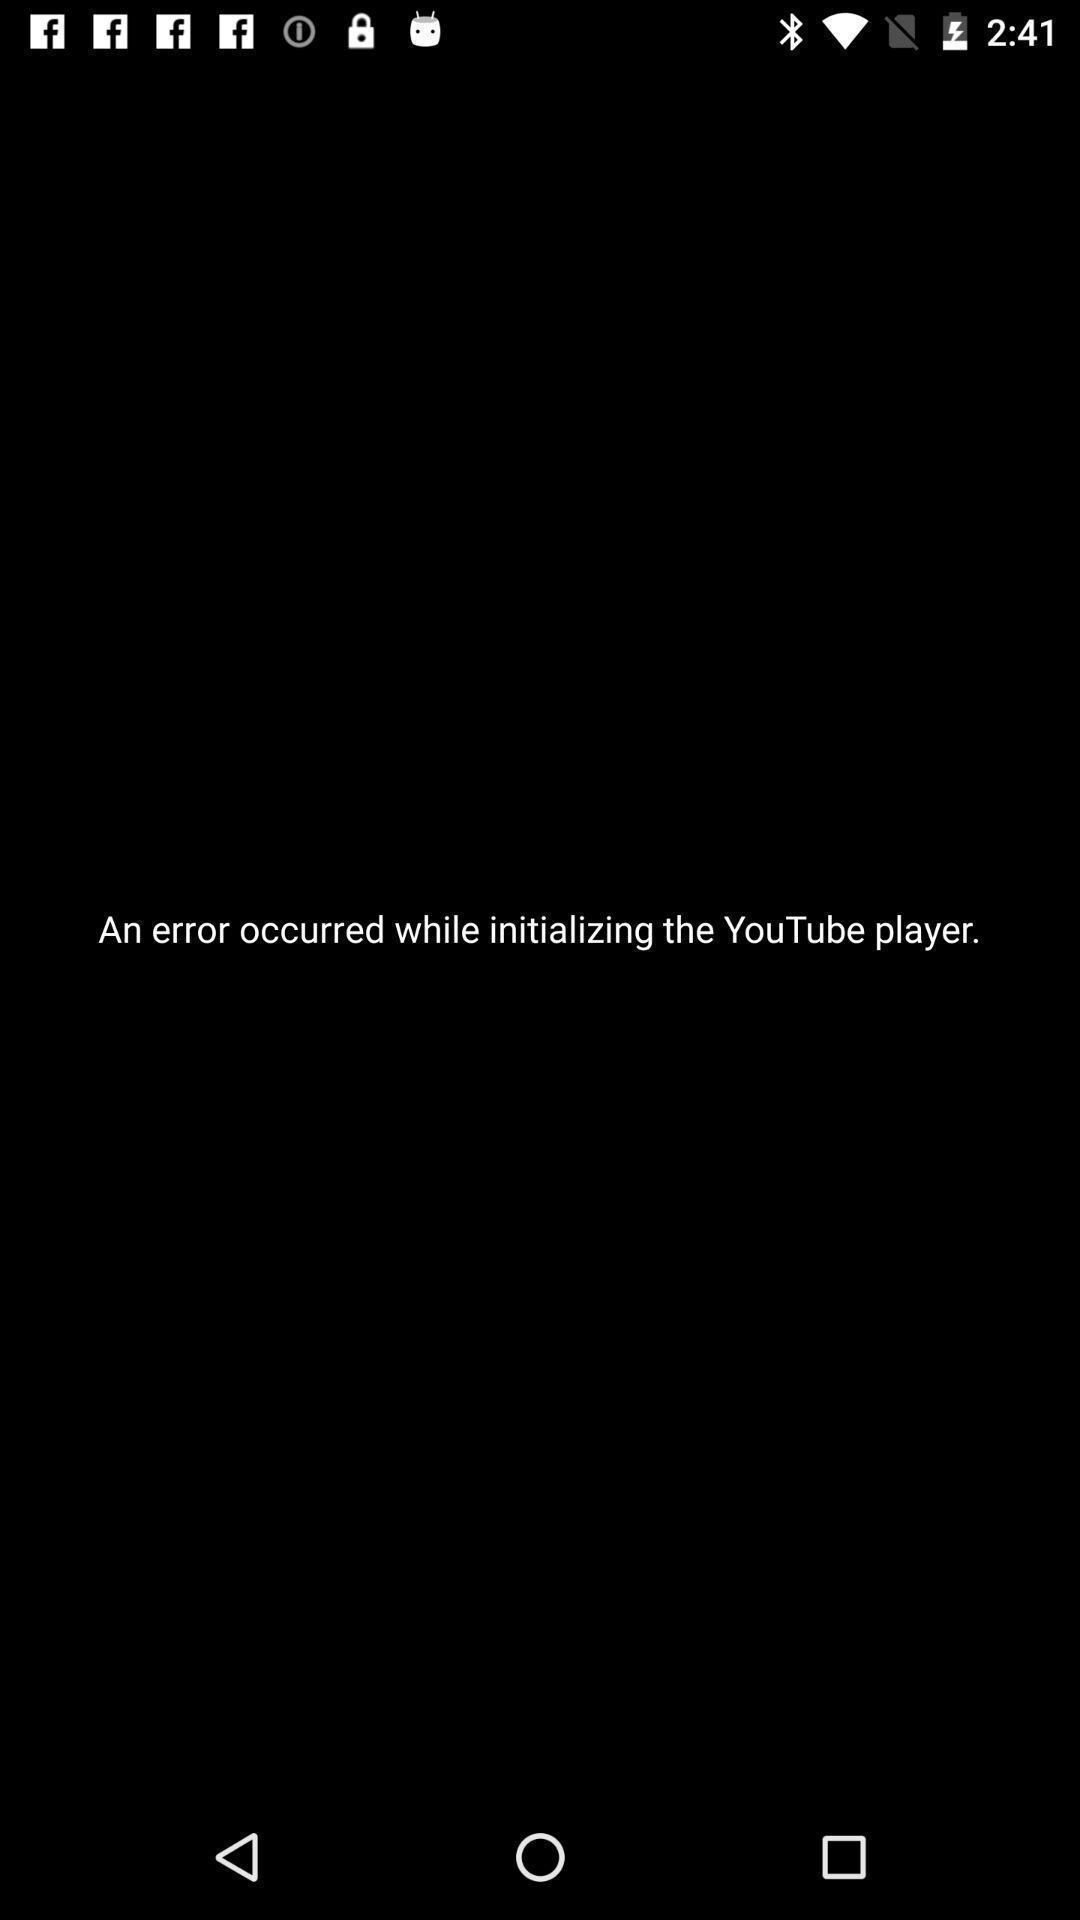Tell me about the visual elements in this screen capture. Screen displaying error page of app. 